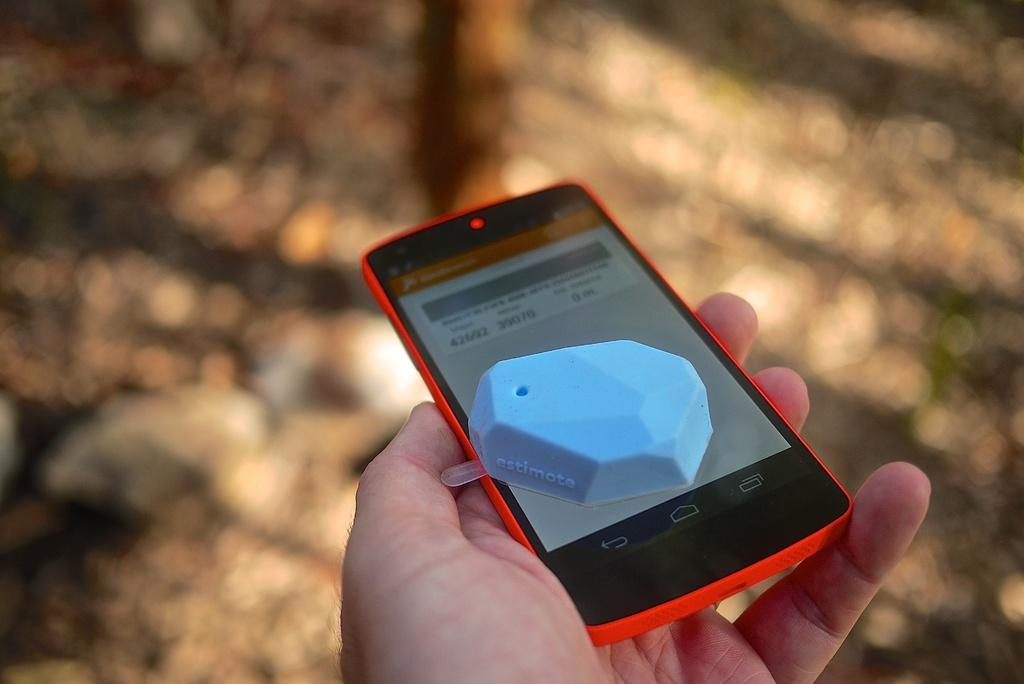<image>
Create a compact narrative representing the image presented. a cell phone with a blue plastic thing on it reading Estimote is held in the woods 